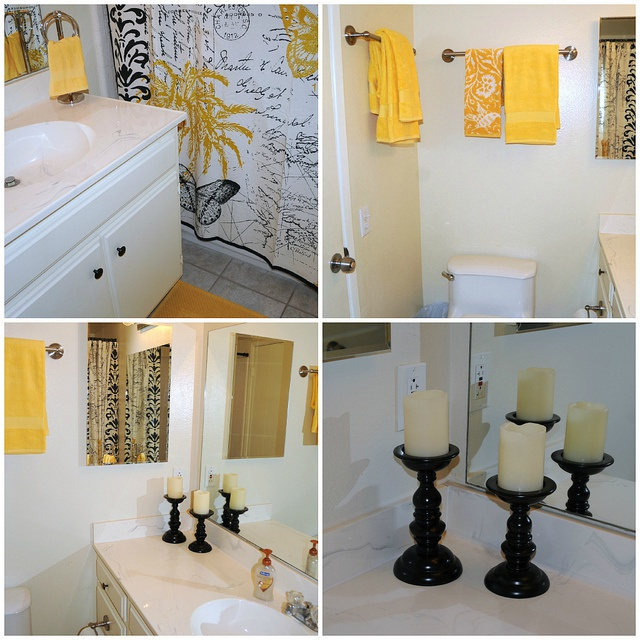Describe the objects in this image and their specific colors. I can see sink in white, lightgray, tan, and darkgray tones, toilet in white, darkgray, and lightgray tones, sink in white, lightgray, darkgray, and gray tones, and toilet in white, darkgray, and gray tones in this image. 